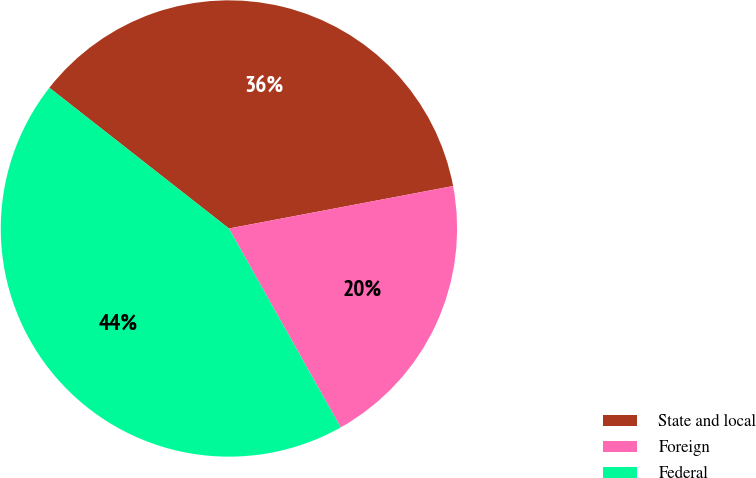<chart> <loc_0><loc_0><loc_500><loc_500><pie_chart><fcel>State and local<fcel>Foreign<fcel>Federal<nl><fcel>36.44%<fcel>19.83%<fcel>43.73%<nl></chart> 